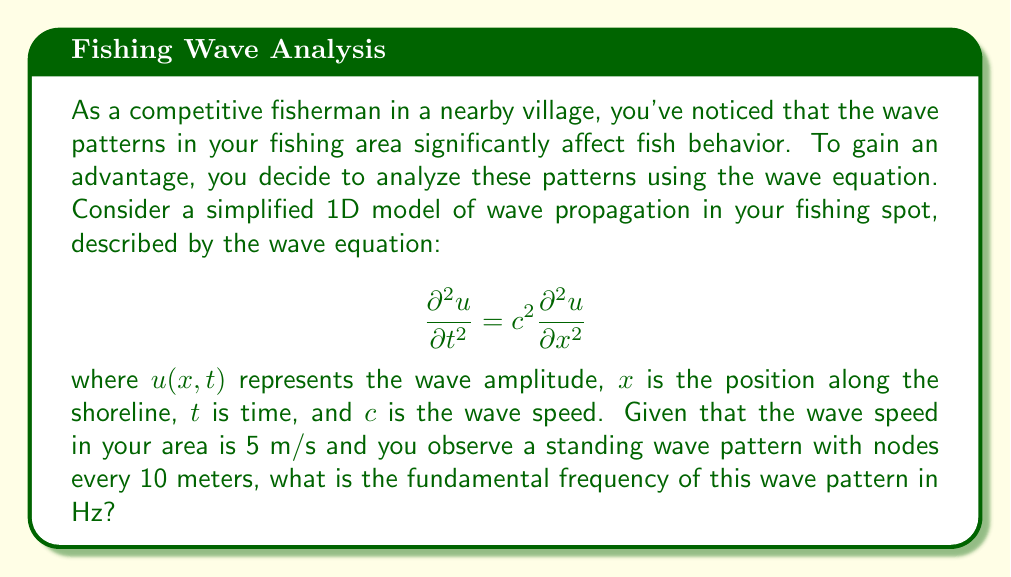Help me with this question. To solve this problem, we need to follow these steps:

1) For a standing wave, the wavelength $\lambda$ is related to the distance between nodes. Since the nodes are 10 meters apart, the wavelength is twice this distance:

   $\lambda = 2 \cdot 10 = 20$ meters

2) We know the wave speed $c = 5$ m/s. In a wave, the speed, wavelength, and frequency are related by the equation:

   $$c = f\lambda$$

3) Rearranging this equation to solve for frequency:

   $$f = \frac{c}{\lambda}$$

4) Substituting our known values:

   $$f = \frac{5 \text{ m/s}}{20 \text{ m}} = 0.25 \text{ Hz}$$

This frequency represents the fundamental frequency of the standing wave pattern. It's the lowest frequency that satisfies the boundary conditions of the wave equation in this scenario.

Note: In the context of fishing, understanding this frequency could help predict periodic changes in water movement, which might influence fish behavior or the effectiveness of certain fishing techniques.
Answer: 0.25 Hz 